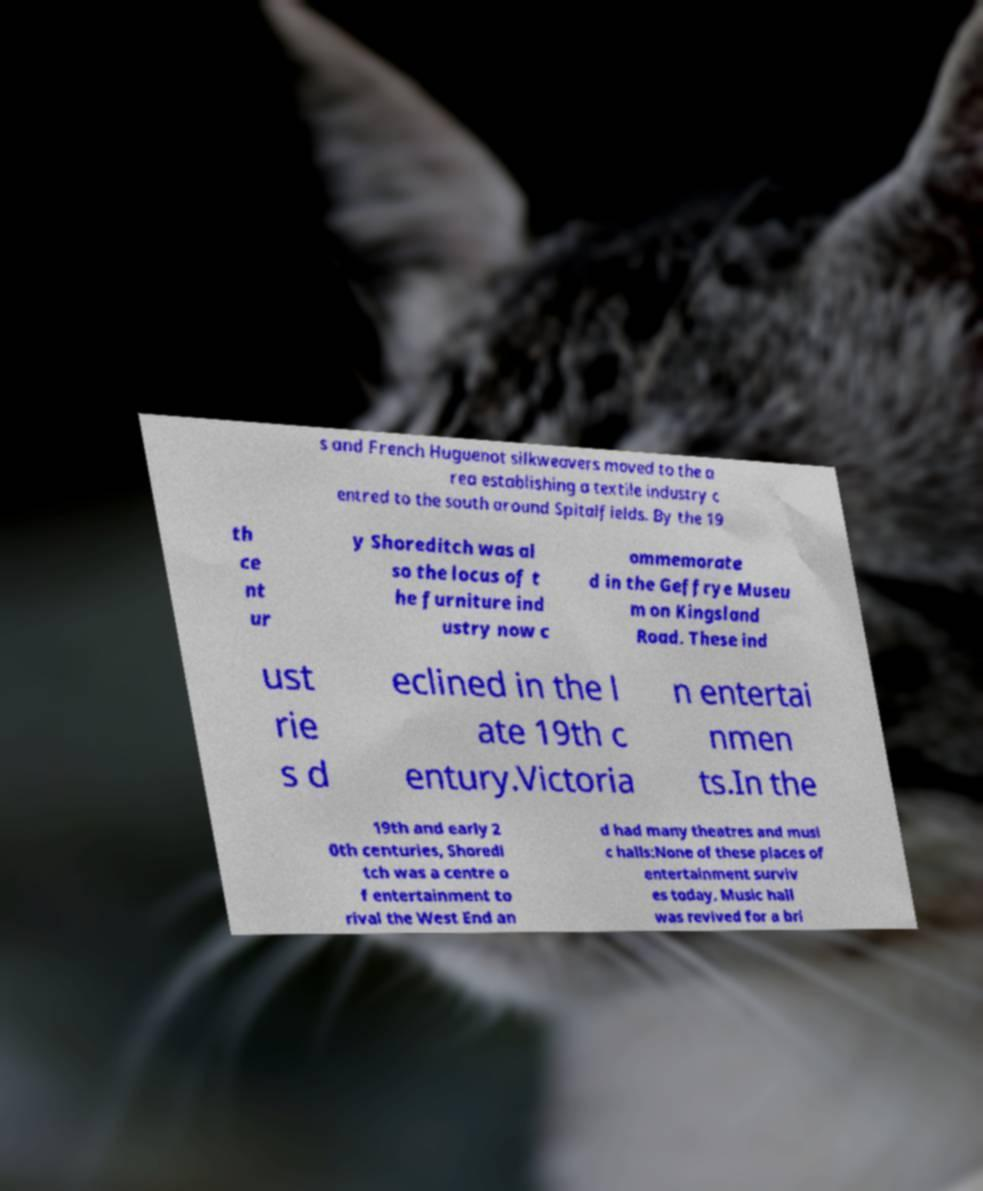Could you extract and type out the text from this image? s and French Huguenot silkweavers moved to the a rea establishing a textile industry c entred to the south around Spitalfields. By the 19 th ce nt ur y Shoreditch was al so the locus of t he furniture ind ustry now c ommemorate d in the Geffrye Museu m on Kingsland Road. These ind ust rie s d eclined in the l ate 19th c entury.Victoria n entertai nmen ts.In the 19th and early 2 0th centuries, Shoredi tch was a centre o f entertainment to rival the West End an d had many theatres and musi c halls:None of these places of entertainment surviv es today. Music hall was revived for a bri 